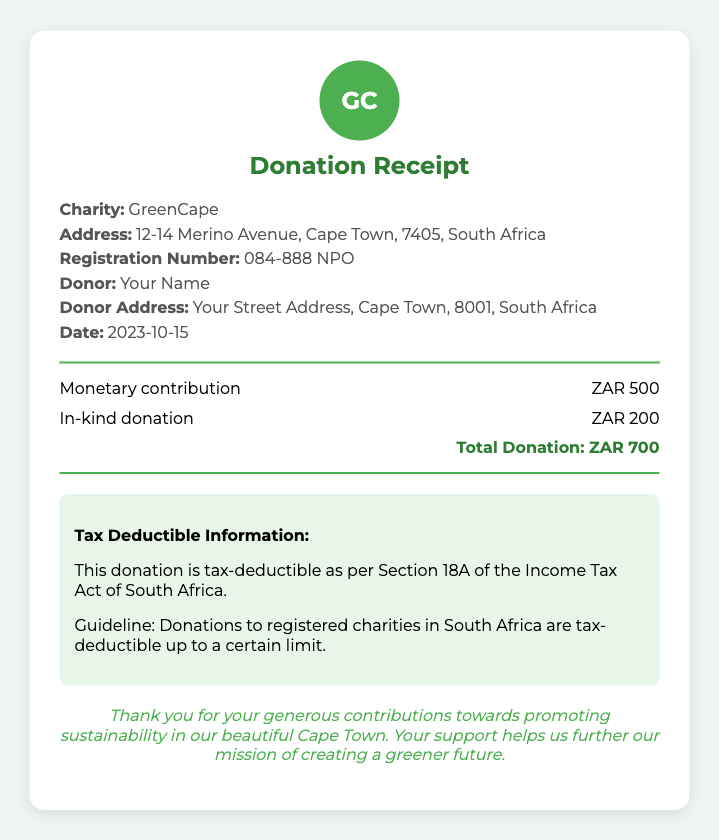What is the charity's name? The charity's name is stated prominently in the details section of the receipt.
Answer: GreenCape What is the total donation amount? The total donation amount is clearly specified at the bottom of the donation list section.
Answer: ZAR 700 What is the date of the donation? The date of the donation is provided in the details section of the receipt.
Answer: 2023-10-15 What type of donation is included? The document lists different types of donations in the donation list section.
Answer: Monetary contribution and In-kind donation What is the registration number of the charity? The registration number is listed in the details section and identifies the charity's official status.
Answer: 084-888 NPO Is the donation tax-deductible? The document specifically states whether the donation is tax-deductible under South African law.
Answer: Yes How much was the in-kind donation? The amount of the in-kind donation is shown in the donation itemized list.
Answer: ZAR 200 What is the address of the charity? The charity's address is detailed in the receipt, providing its physical location.
Answer: 12-14 Merino Avenue, Cape Town, 7405, South Africa What is the donor's address? The donor's address can be found in the personal details section of the receipt.
Answer: Your Street Address, Cape Town, 8001, South Africa 